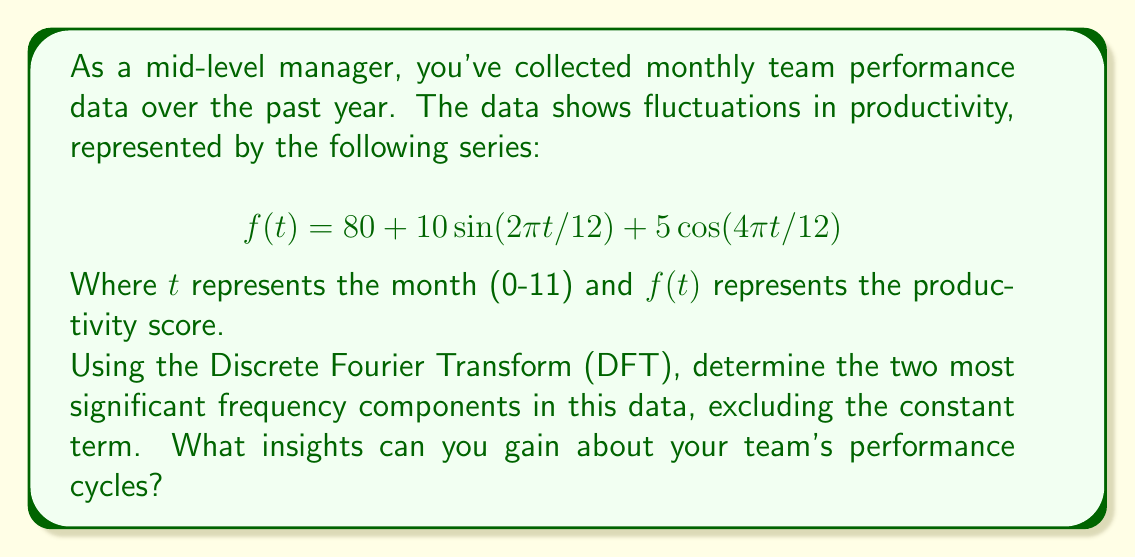Give your solution to this math problem. To analyze the frequency components of the team performance data, we'll follow these steps:

1) First, let's recall the general form of the Discrete Fourier Transform (DFT):

   $$ F(k) = \sum_{n=0}^{N-1} f(n) e^{-i2\pi kn/N} $$

   Where $N$ is the number of data points (12 in this case), $k$ is the frequency index, and $n$ is the time index.

2) In our case, we already have the function in the frequency domain:

   $$ f(t) = 80 + 10\sin(2\pi t/12) + 5\cos(4\pi t/12) $$

3) We can rewrite this using Euler's formula:

   $$ f(t) = 80 + 5i(e^{i2\pi t/12} - e^{-i2\pi t/12}) + \frac{5}{2}(e^{i4\pi t/12} + e^{-i4\pi t/12}) $$

4) Comparing this to the general form of a Fourier series:

   $$ f(t) = \sum_{k=-\infty}^{\infty} c_k e^{i2\pi kt/N} $$

   We can identify the frequency components:

   - $c_0 = 80$ (constant term)
   - $c_1 = c_{-1} = 5i$ (frequency $k=1$)
   - $c_2 = c_{-2} = 2.5$ (frequency $k=2$)

5) The magnitude of these components are:

   - $|c_1| = |c_{-1}| = 5$
   - $|c_2| = |c_{-2}| = 2.5$

6) Therefore, the two most significant frequency components (excluding the constant term) are:

   - $k=1$, with magnitude 5
   - $k=2$, with magnitude 2.5

Interpreting these results:

- The $k=1$ component represents a cycle that completes once per year (12 months).
- The $k=2$ component represents a cycle that completes twice per year (every 6 months).

As a manager, you can conclude that your team's performance has:
1) A major annual cycle (possibly related to yearly goals or seasons)
2) A secondary biannual cycle (possibly related to half-year evaluations or project cycles)

Understanding these cycles can help in planning, setting expectations, and potentially implementing interventions to smooth out performance over time.
Answer: The two most significant frequency components are:
1) $k=1$ with magnitude 5, representing an annual cycle
2) $k=2$ with magnitude 2.5, representing a biannual cycle

These suggest that team performance is influenced by both yearly and half-yearly factors, which can inform management decisions on goal-setting and performance evaluation timing. 